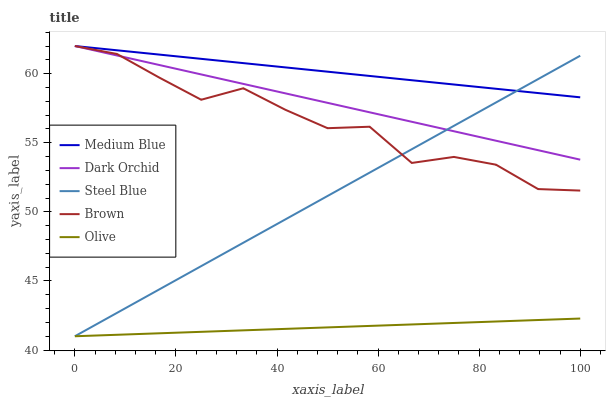Does Olive have the minimum area under the curve?
Answer yes or no. Yes. Does Medium Blue have the maximum area under the curve?
Answer yes or no. Yes. Does Brown have the minimum area under the curve?
Answer yes or no. No. Does Brown have the maximum area under the curve?
Answer yes or no. No. Is Medium Blue the smoothest?
Answer yes or no. Yes. Is Brown the roughest?
Answer yes or no. Yes. Is Brown the smoothest?
Answer yes or no. No. Is Medium Blue the roughest?
Answer yes or no. No. Does Olive have the lowest value?
Answer yes or no. Yes. Does Brown have the lowest value?
Answer yes or no. No. Does Dark Orchid have the highest value?
Answer yes or no. Yes. Does Steel Blue have the highest value?
Answer yes or no. No. Is Olive less than Dark Orchid?
Answer yes or no. Yes. Is Brown greater than Olive?
Answer yes or no. Yes. Does Dark Orchid intersect Medium Blue?
Answer yes or no. Yes. Is Dark Orchid less than Medium Blue?
Answer yes or no. No. Is Dark Orchid greater than Medium Blue?
Answer yes or no. No. Does Olive intersect Dark Orchid?
Answer yes or no. No. 